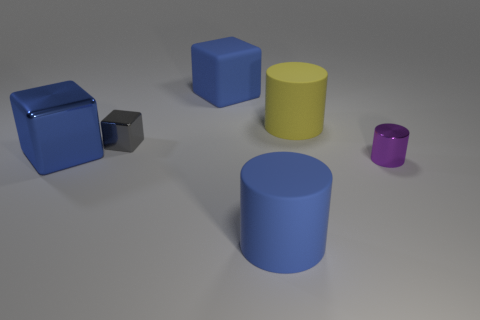Add 2 balls. How many objects exist? 8 Add 6 blocks. How many blocks are left? 9 Add 1 tiny gray spheres. How many tiny gray spheres exist? 1 Subtract 0 green balls. How many objects are left? 6 Subtract all small rubber spheres. Subtract all yellow matte things. How many objects are left? 5 